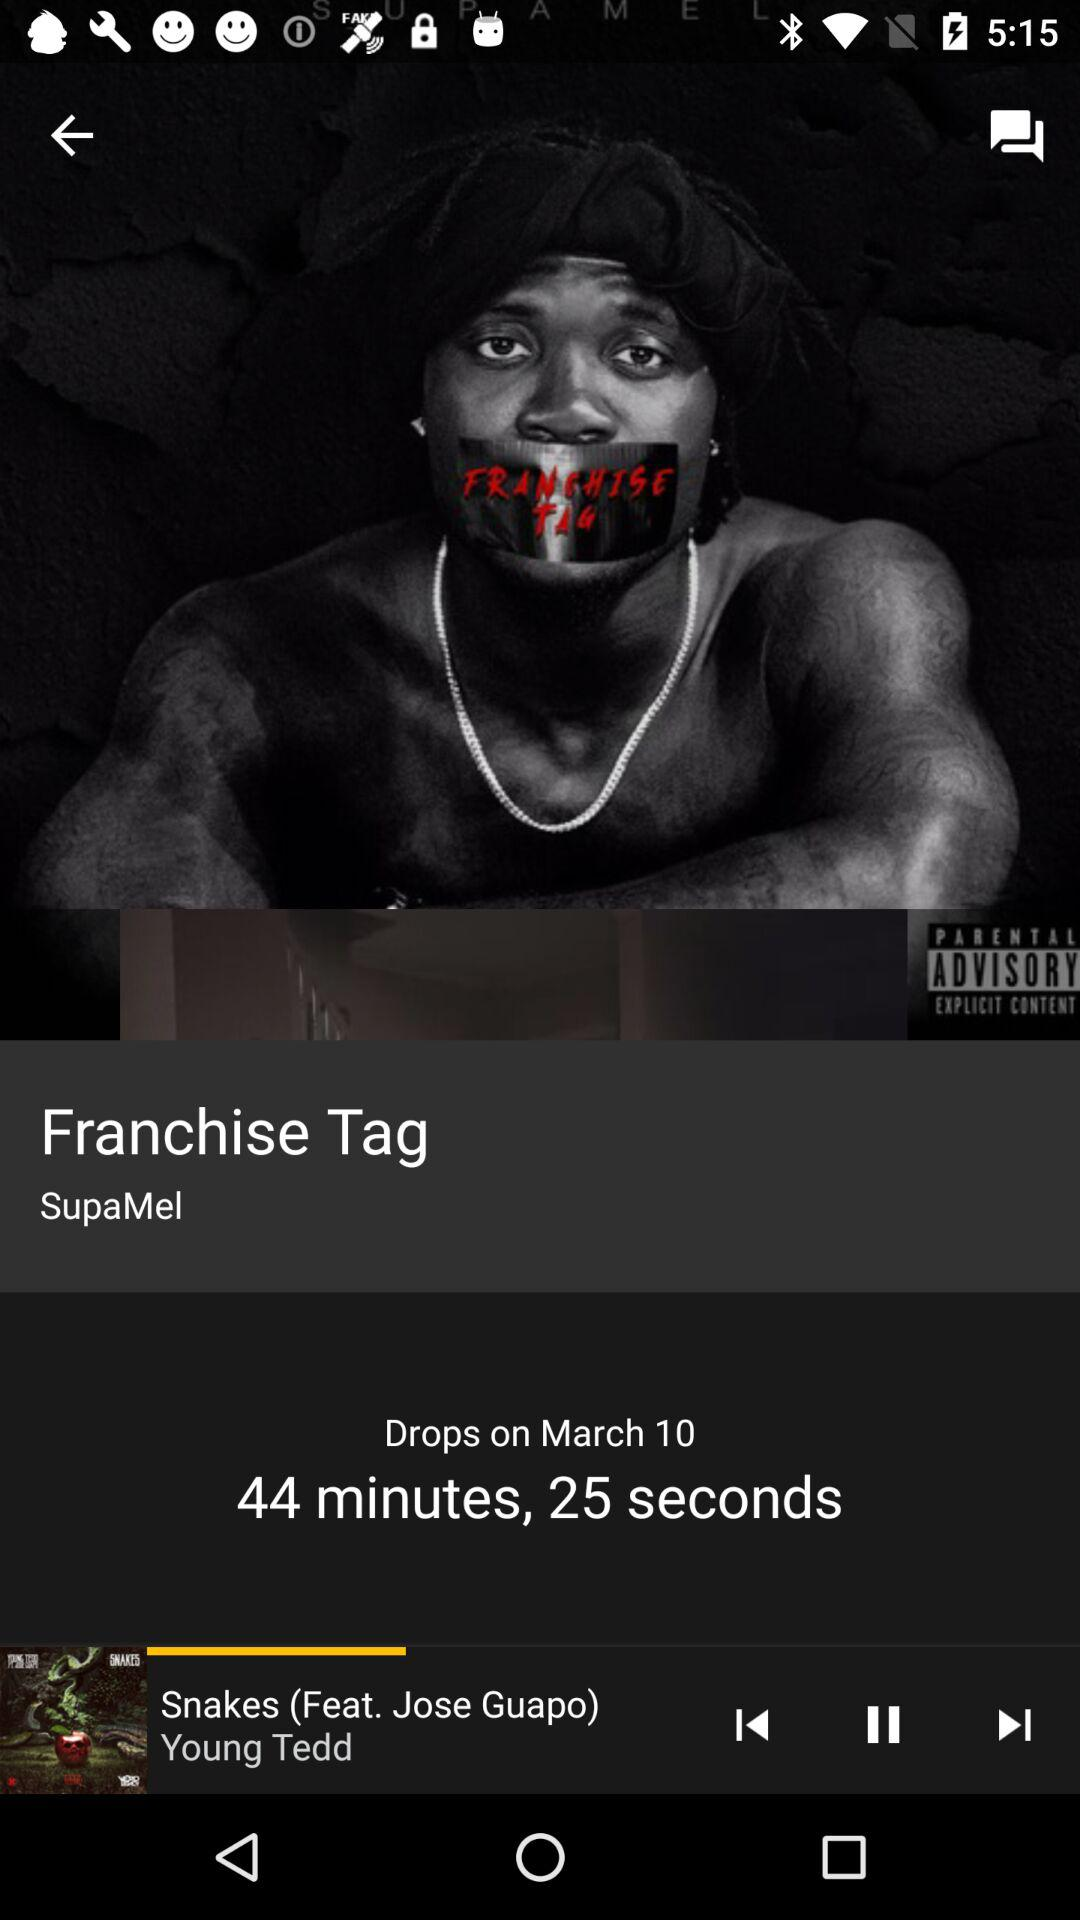What is the duration? The duration is 44 minutes 25 seconds. 